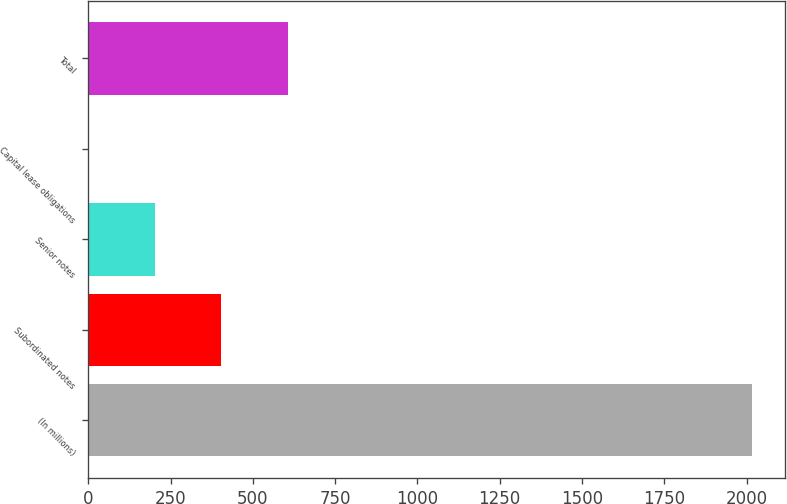Convert chart to OTSL. <chart><loc_0><loc_0><loc_500><loc_500><bar_chart><fcel>(In millions)<fcel>Subordinated notes<fcel>Senior notes<fcel>Capital lease obligations<fcel>Total<nl><fcel>2017<fcel>404.2<fcel>202.6<fcel>1<fcel>605.8<nl></chart> 